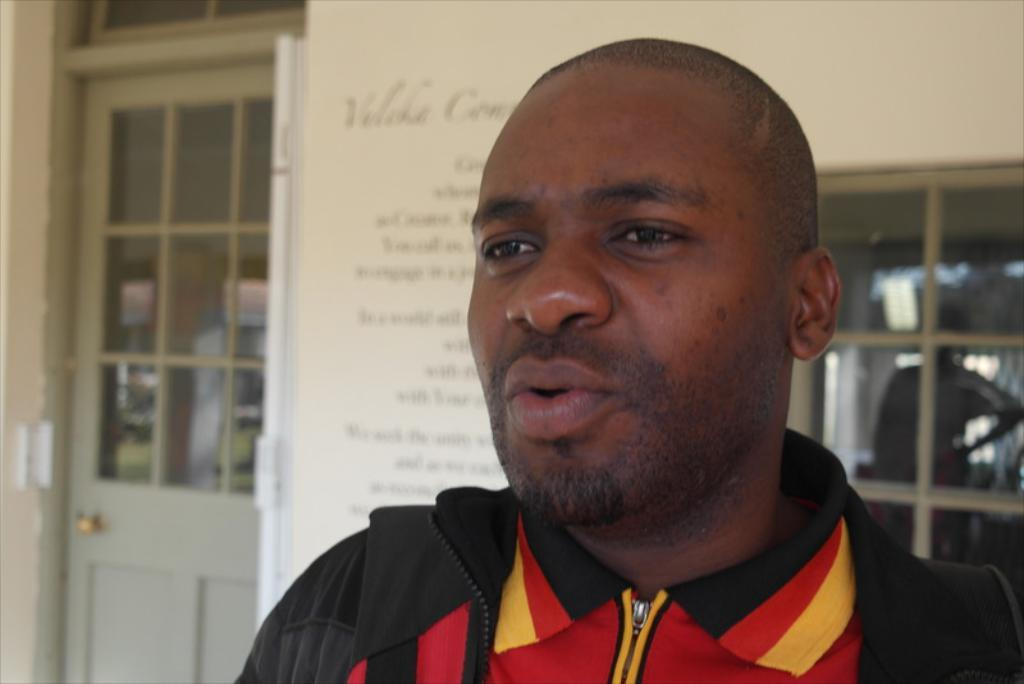Who is present in the image? There is a man in the image. What is the man doing in the image? The man is speaking. What can be seen in the background of the image? There is a door, a window, and a board in the background of the image. What type of soda is the man drinking in the image? There is no soda present in the image; the man is speaking. 